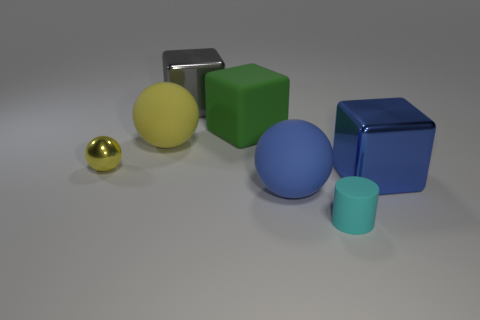Are there any small cyan rubber cylinders right of the tiny yellow shiny sphere?
Provide a succinct answer. Yes. Is there a green block that has the same material as the cyan cylinder?
Provide a succinct answer. Yes. How many balls are big blue metal objects or rubber things?
Your response must be concise. 2. Is the number of matte objects behind the blue metallic cube greater than the number of blue rubber balls that are on the left side of the big green thing?
Ensure brevity in your answer.  Yes. What number of large balls have the same color as the tiny sphere?
Ensure brevity in your answer.  1. What is the size of the cylinder that is made of the same material as the green object?
Provide a short and direct response. Small. How many things are blocks that are on the left side of the tiny cyan cylinder or small blue matte cubes?
Offer a terse response. 2. There is a matte sphere that is behind the tiny shiny ball; is it the same color as the small shiny thing?
Ensure brevity in your answer.  Yes. What is the size of the other matte object that is the same shape as the yellow rubber object?
Provide a succinct answer. Large. There is a cube in front of the yellow matte object that is in front of the shiny cube on the left side of the cyan rubber cylinder; what color is it?
Your answer should be very brief. Blue. 